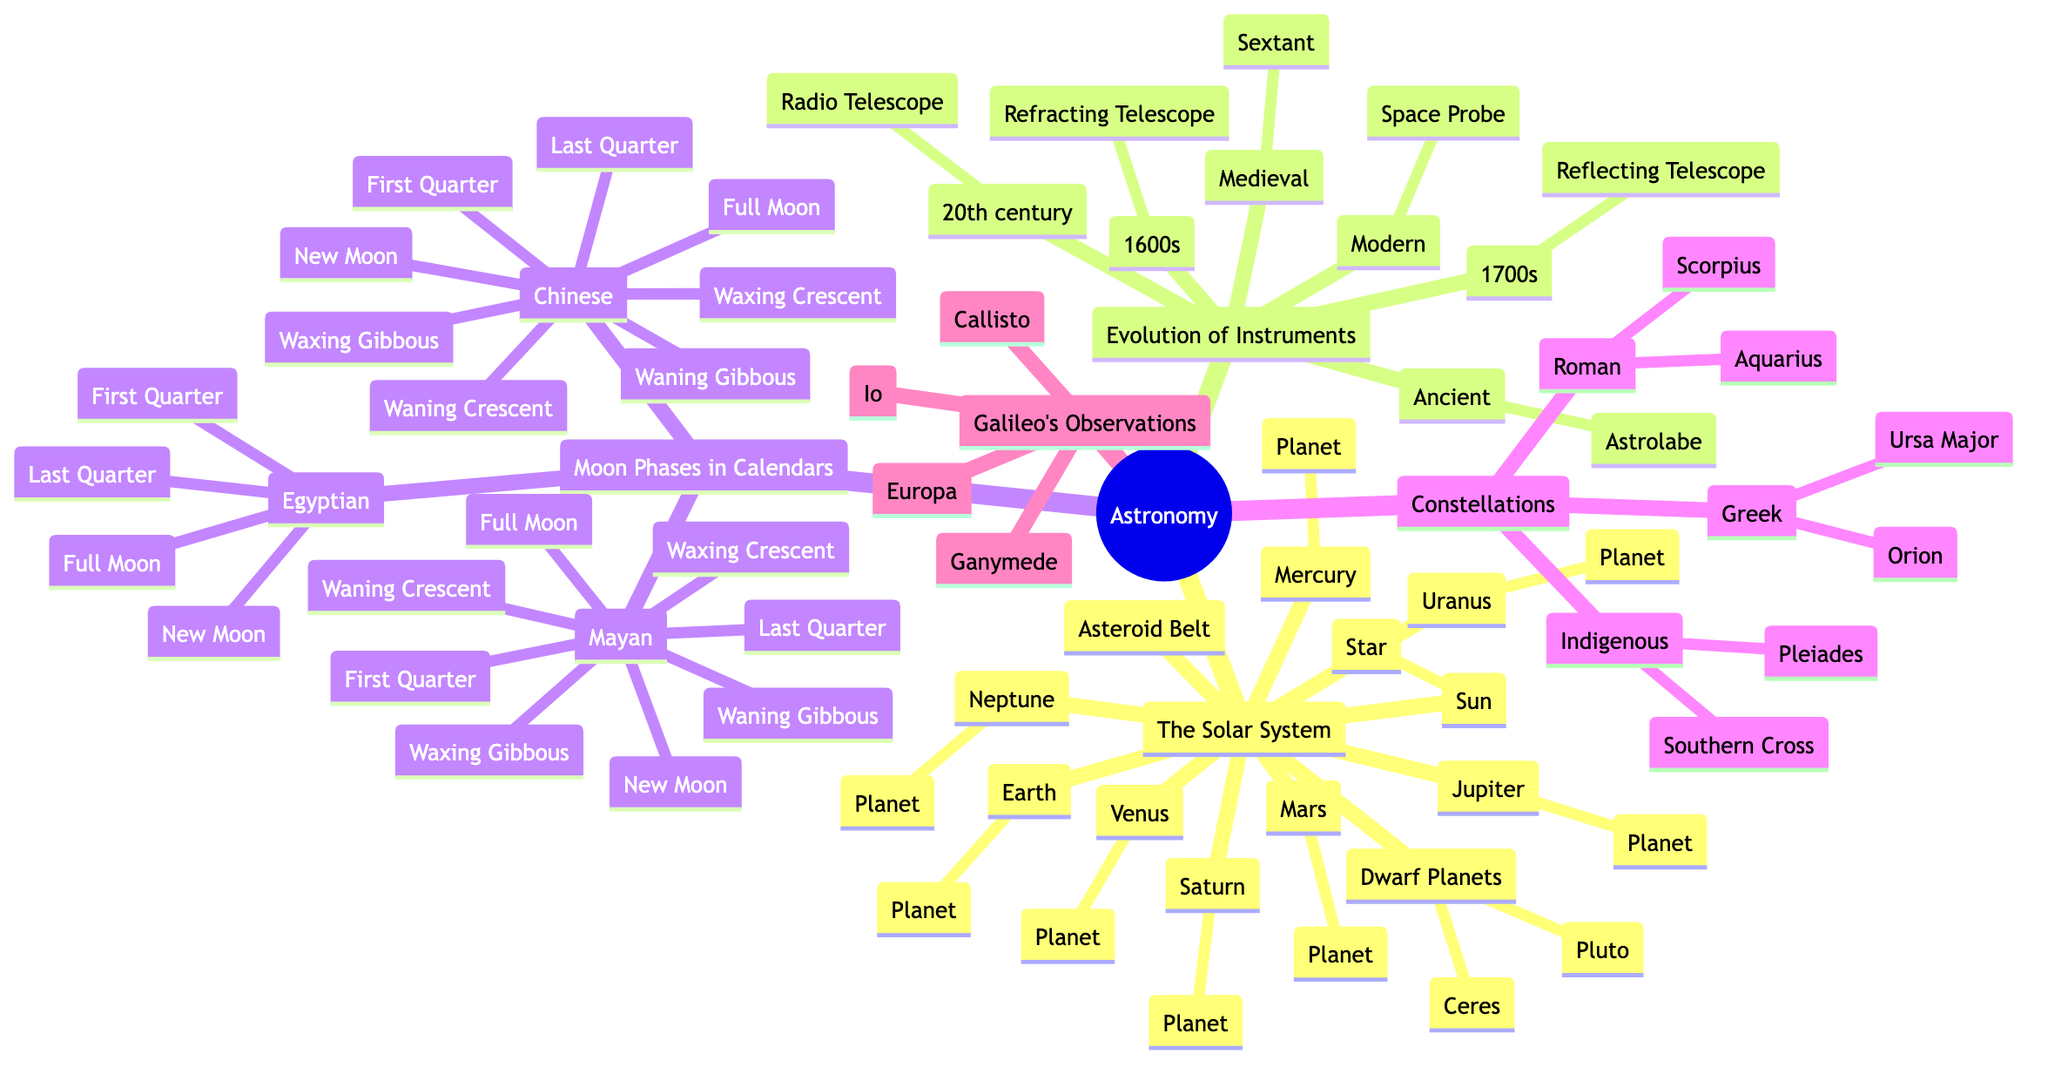What is the central star of the Solar System? The diagram denotes the "Sun" as the central star, indicating its primary role in the Solar System as the main source of light and energy.
Answer: Sun How many major planets are in the Solar System as depicted? By counting the planets listed under "The Solar System," there are eight major planets: Mercury, Venus, Earth, Mars, Jupiter, Saturn, Uranus, and Neptune.
Answer: Eight Which ancient instrument is represented as a tool for navigation? The diagram includes "Astrolabe" under the "Ancient" category, showcasing its historical significance as an early navigational tool.
Answer: Astrolabe List two moon phases from the Mayan calendar. The diagram displays multiple phases under "Mayan," including "New Moon" and "Full Moon," which are key phases recognized by the Mayan culture.
Answer: New Moon, Full Moon Which constellations are attributed to Roman culture? The diagram identifies "Aquarius" and "Scorpius" under the "Roman" section, highlighting their importance in Roman star lore.
Answer: Aquarius, Scorpius How many moons did Galileo observe around Jupiter? The document specifies four moons: Io, Europa, Ganymede, and Callisto, which were the key observations made by Galileo.
Answer: Four What type of telescope emerged in the 1700s? The diagram lists "Reflecting Telescope" as the advancement in astronomical instruments during the 1700s, marking a significant technological evolution.
Answer: Reflecting Telescope Identify one Indigenous constellation from the diagram. The diagram shows "Pleiades" as one of the constellations linked to Indigenous cultural astronomy, highlighting its significance in their sky lore.
Answer: Pleiades Which modern tool allows for space exploration according to the diagram? The diagram indicates "Space Probe" as a modern instrument, serving as a tool for exploring celestial bodies beyond Earth.
Answer: Space Probe What was the purpose of the Sextant in medieval times? While the diagram does not explicitly state its purpose, the contextually placed "Sextant" under "Medieval" suggests it was utilized for navigation and measuring angles.
Answer: Navigation 